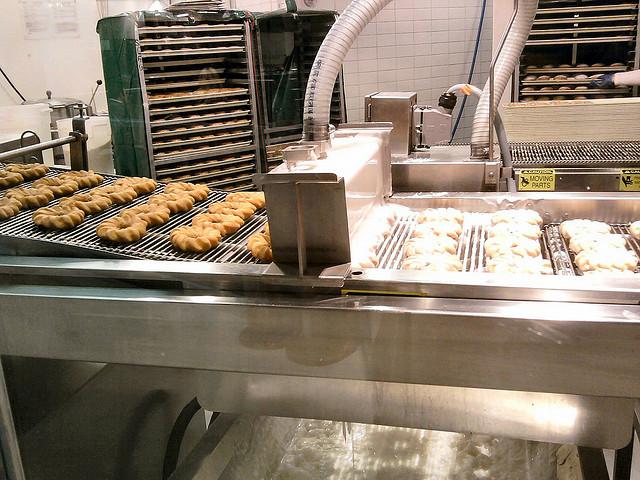What food item is being made?
Write a very short answer. Donuts. Is this photo taken at a bakery?
Write a very short answer. Yes. What color is the oven?
Short answer required. Silver. 